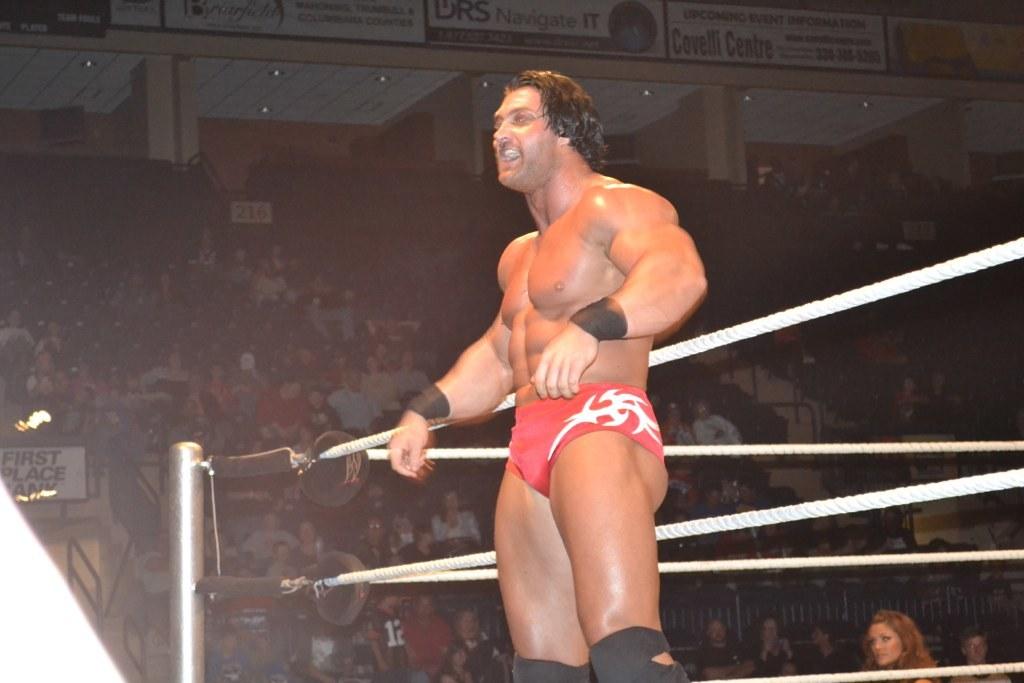This image is proffesional wrestlering?
Provide a succinct answer. Yes. 